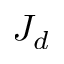<formula> <loc_0><loc_0><loc_500><loc_500>J _ { d }</formula> 